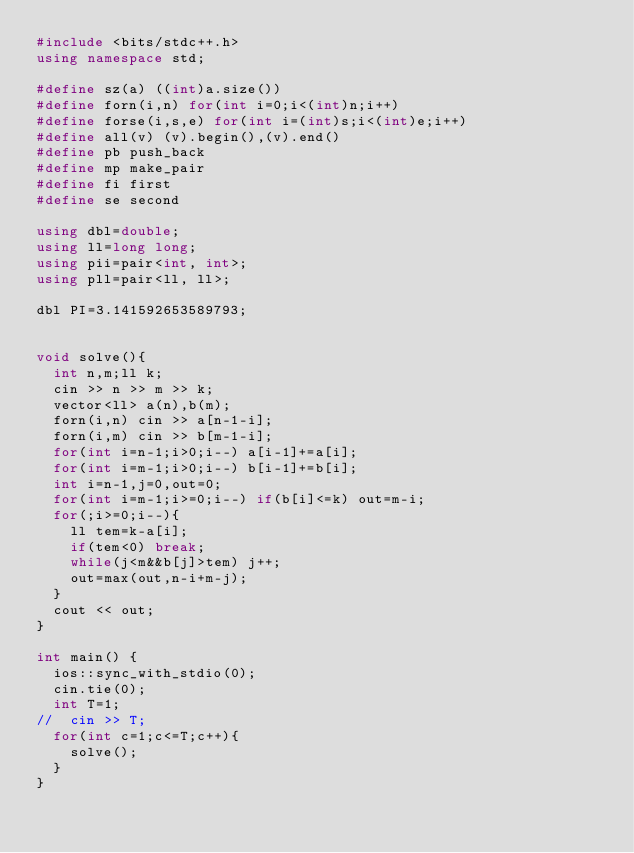<code> <loc_0><loc_0><loc_500><loc_500><_C++_>#include <bits/stdc++.h>
using namespace std;

#define sz(a) ((int)a.size())
#define forn(i,n) for(int i=0;i<(int)n;i++)
#define forse(i,s,e) for(int i=(int)s;i<(int)e;i++)
#define all(v) (v).begin(),(v).end()
#define pb push_back
#define mp make_pair
#define fi first
#define se second

using dbl=double;
using ll=long long;
using pii=pair<int, int>;
using pll=pair<ll, ll>;

dbl PI=3.141592653589793;


void solve(){
	int n,m;ll k;
	cin >> n >> m >> k;
	vector<ll> a(n),b(m);
	forn(i,n) cin >> a[n-1-i];
	forn(i,m) cin >> b[m-1-i];
	for(int i=n-1;i>0;i--) a[i-1]+=a[i];
	for(int i=m-1;i>0;i--) b[i-1]+=b[i];
	int i=n-1,j=0,out=0;
	for(int i=m-1;i>=0;i--) if(b[i]<=k) out=m-i;
	for(;i>=0;i--){
		ll tem=k-a[i];
		if(tem<0) break;
		while(j<m&&b[j]>tem) j++;
		out=max(out,n-i+m-j);
	}
	cout << out;
}

int main() {
	ios::sync_with_stdio(0);
	cin.tie(0); 
	int T=1;
//	cin >> T;
	for(int c=1;c<=T;c++){
		solve();
	}
}
</code> 